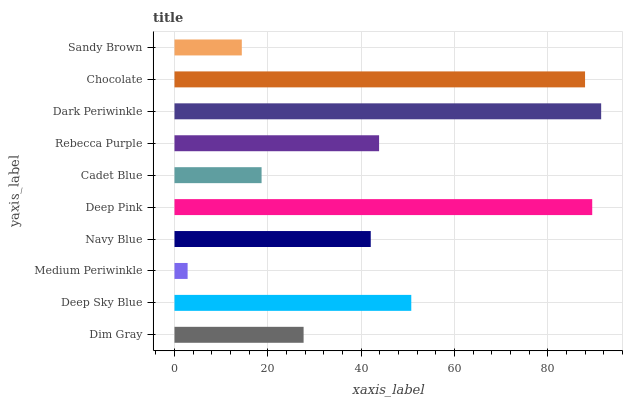Is Medium Periwinkle the minimum?
Answer yes or no. Yes. Is Dark Periwinkle the maximum?
Answer yes or no. Yes. Is Deep Sky Blue the minimum?
Answer yes or no. No. Is Deep Sky Blue the maximum?
Answer yes or no. No. Is Deep Sky Blue greater than Dim Gray?
Answer yes or no. Yes. Is Dim Gray less than Deep Sky Blue?
Answer yes or no. Yes. Is Dim Gray greater than Deep Sky Blue?
Answer yes or no. No. Is Deep Sky Blue less than Dim Gray?
Answer yes or no. No. Is Rebecca Purple the high median?
Answer yes or no. Yes. Is Navy Blue the low median?
Answer yes or no. Yes. Is Deep Sky Blue the high median?
Answer yes or no. No. Is Sandy Brown the low median?
Answer yes or no. No. 